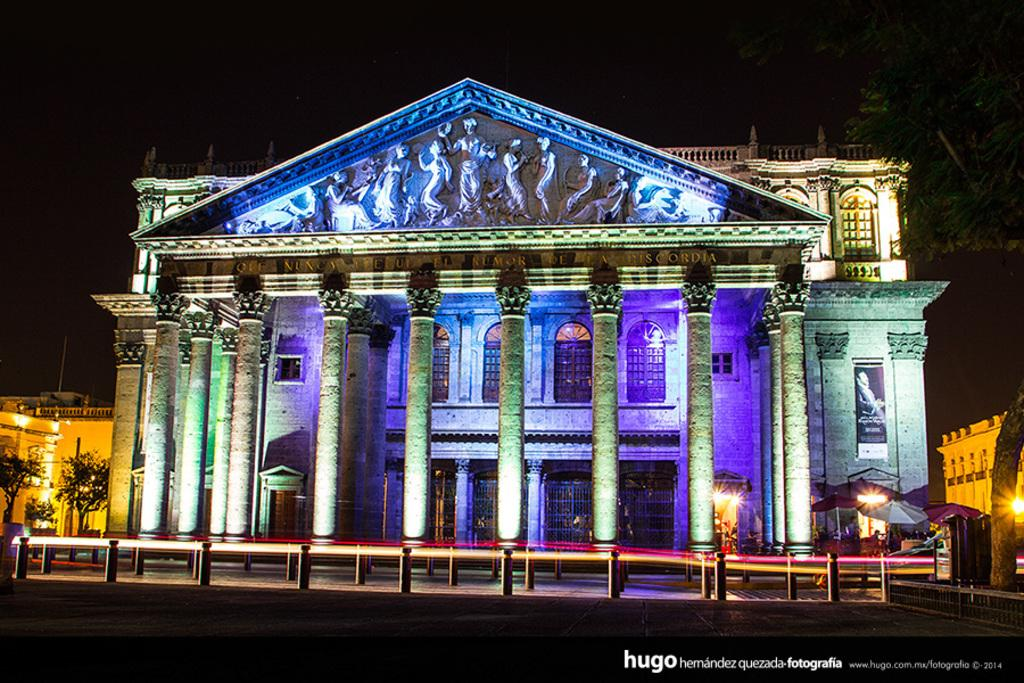What type of structures can be seen in the image? There are buildings in the image. What can be seen illuminating the scene in the image? There are lights in the image. What type of barrier is present in the image? There is fencing in the image. What type of natural elements can be seen in the image? There are trees in the image. How many hands are visible in the image? There are no hands visible in the image. What type of printing can be seen on the buildings in the image? There is no printing visible on the buildings in the image. 